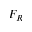<formula> <loc_0><loc_0><loc_500><loc_500>F _ { R }</formula> 